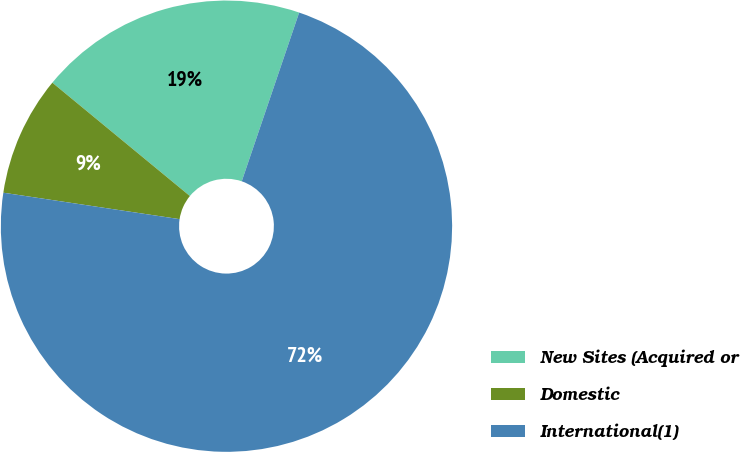<chart> <loc_0><loc_0><loc_500><loc_500><pie_chart><fcel>New Sites (Acquired or<fcel>Domestic<fcel>International(1)<nl><fcel>19.25%<fcel>8.6%<fcel>72.15%<nl></chart> 